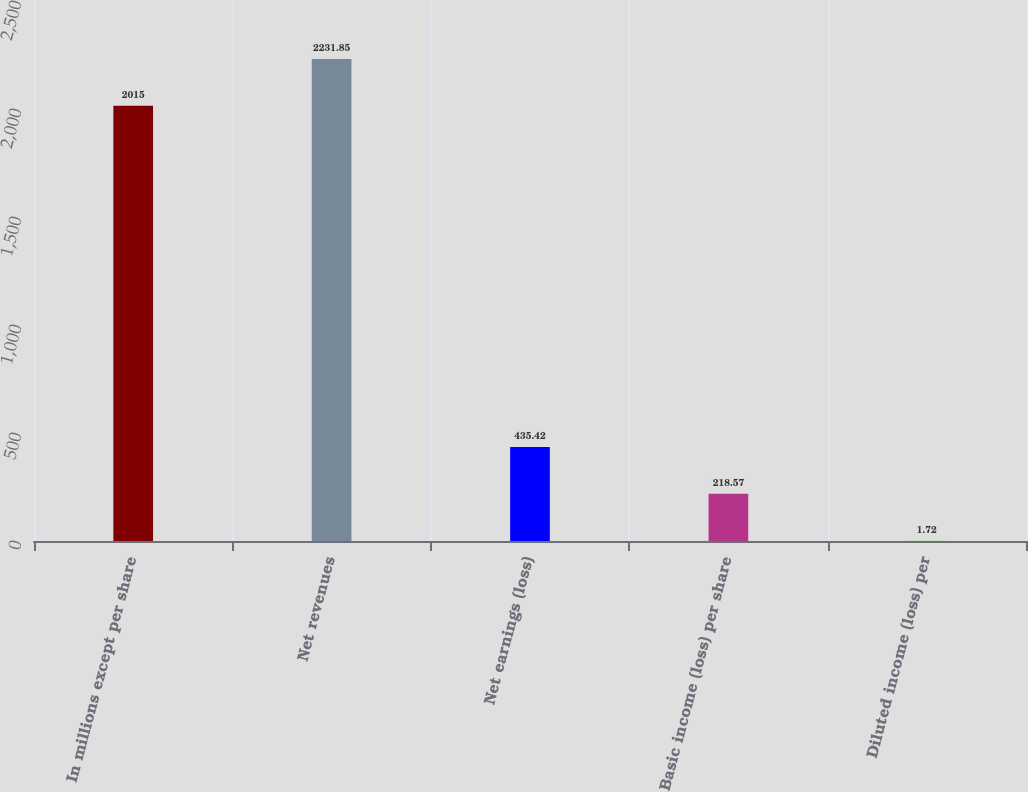<chart> <loc_0><loc_0><loc_500><loc_500><bar_chart><fcel>In millions except per share<fcel>Net revenues<fcel>Net earnings (loss)<fcel>Basic income (loss) per share<fcel>Diluted income (loss) per<nl><fcel>2015<fcel>2231.85<fcel>435.42<fcel>218.57<fcel>1.72<nl></chart> 